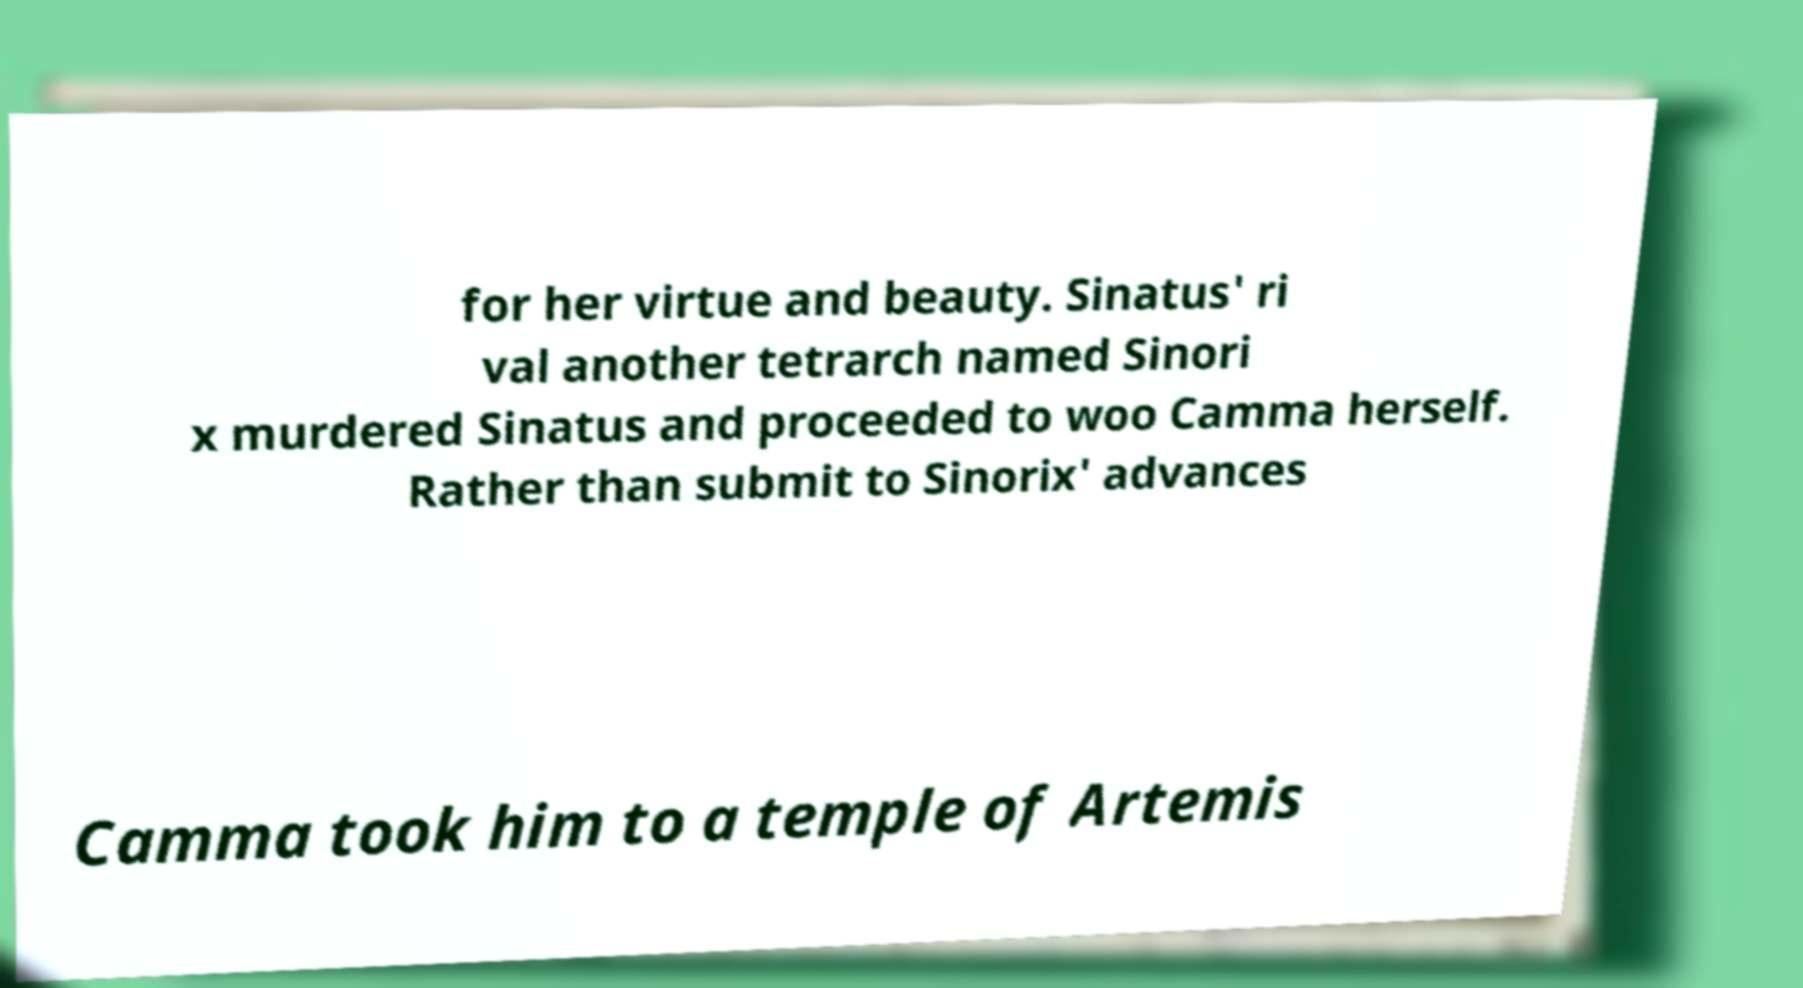Could you assist in decoding the text presented in this image and type it out clearly? for her virtue and beauty. Sinatus' ri val another tetrarch named Sinori x murdered Sinatus and proceeded to woo Camma herself. Rather than submit to Sinorix' advances Camma took him to a temple of Artemis 